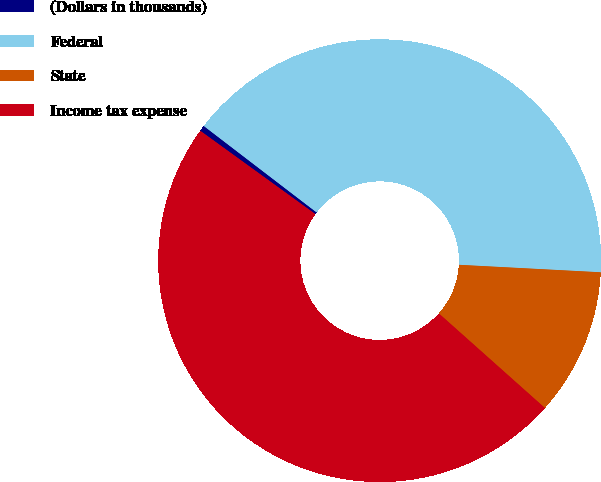Convert chart. <chart><loc_0><loc_0><loc_500><loc_500><pie_chart><fcel>(Dollars in thousands)<fcel>Federal<fcel>State<fcel>Income tax expense<nl><fcel>0.43%<fcel>40.44%<fcel>10.75%<fcel>48.39%<nl></chart> 